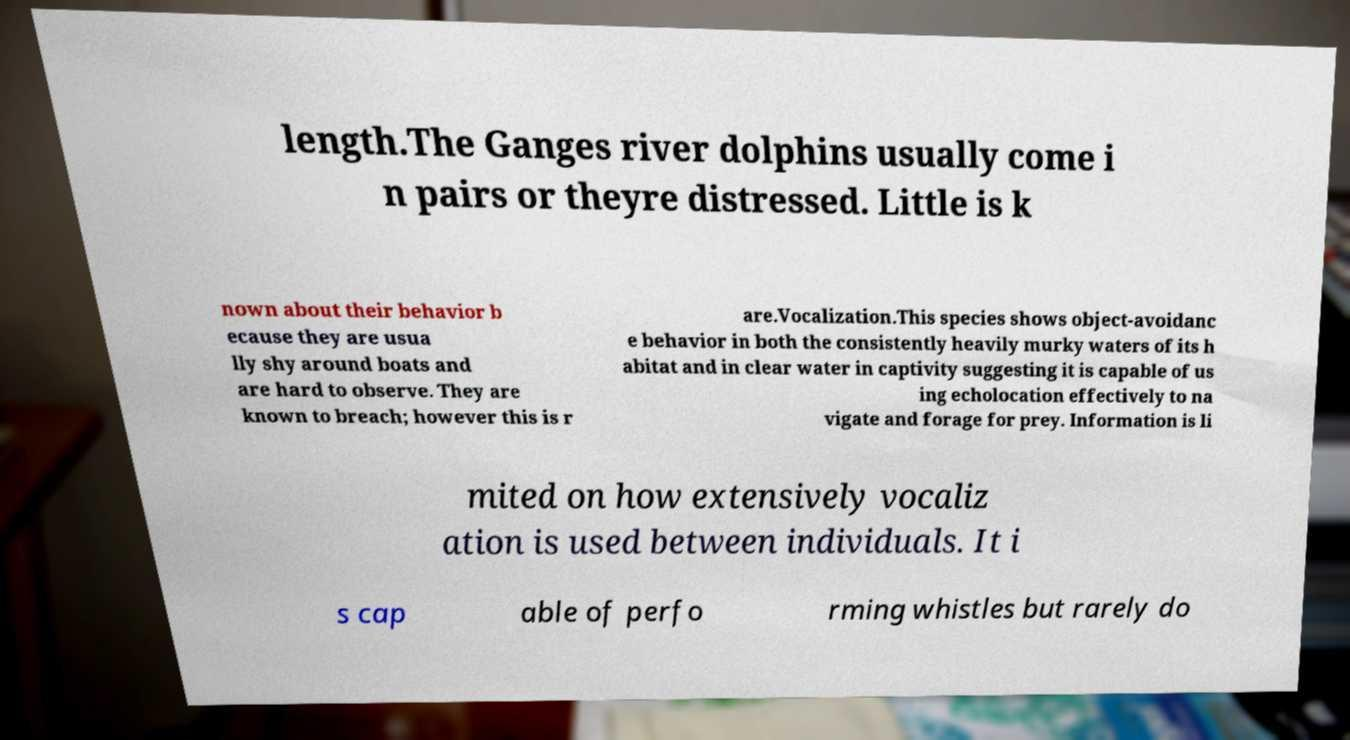Please identify and transcribe the text found in this image. length.The Ganges river dolphins usually come i n pairs or theyre distressed. Little is k nown about their behavior b ecause they are usua lly shy around boats and are hard to observe. They are known to breach; however this is r are.Vocalization.This species shows object-avoidanc e behavior in both the consistently heavily murky waters of its h abitat and in clear water in captivity suggesting it is capable of us ing echolocation effectively to na vigate and forage for prey. Information is li mited on how extensively vocaliz ation is used between individuals. It i s cap able of perfo rming whistles but rarely do 